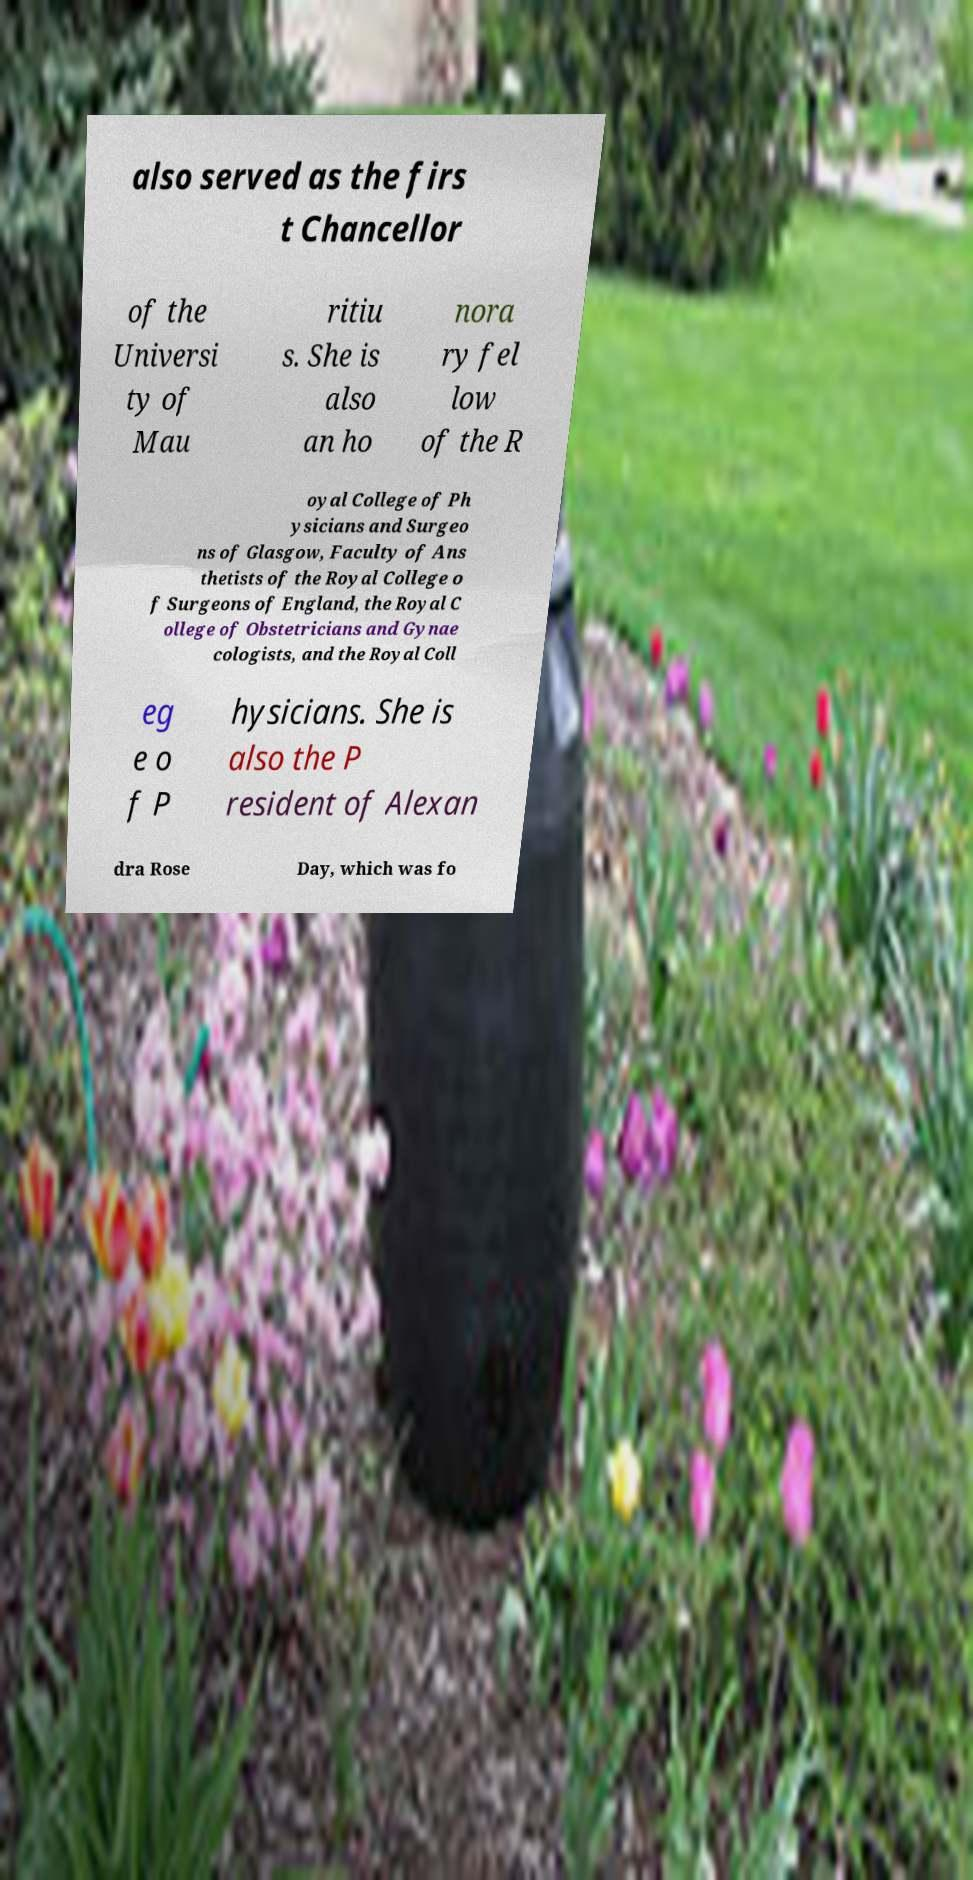What messages or text are displayed in this image? I need them in a readable, typed format. also served as the firs t Chancellor of the Universi ty of Mau ritiu s. She is also an ho nora ry fel low of the R oyal College of Ph ysicians and Surgeo ns of Glasgow, Faculty of Ans thetists of the Royal College o f Surgeons of England, the Royal C ollege of Obstetricians and Gynae cologists, and the Royal Coll eg e o f P hysicians. She is also the P resident of Alexan dra Rose Day, which was fo 